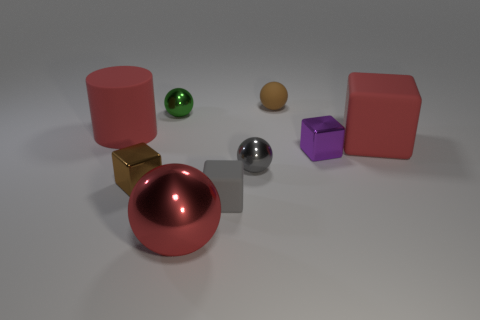What shape is the large metallic object that is the same color as the big block?
Give a very brief answer. Sphere. The large metal object has what color?
Your answer should be very brief. Red. How big is the matte object in front of the big red block?
Keep it short and to the point. Small. There is a red rubber thing to the right of the gray object behind the tiny brown metallic object; how many small brown shiny objects are behind it?
Keep it short and to the point. 0. What is the color of the large rubber object that is behind the red thing that is on the right side of the gray matte block?
Give a very brief answer. Red. Are there any gray objects of the same size as the brown matte ball?
Make the answer very short. Yes. The brown thing behind the matte block that is to the right of the gray thing that is on the right side of the tiny gray cube is made of what material?
Give a very brief answer. Rubber. What number of tiny brown rubber spheres are in front of the red rubber thing right of the red matte cylinder?
Ensure brevity in your answer.  0. There is a shiny ball that is to the right of the gray cube; does it have the same size as the purple shiny block?
Offer a very short reply. Yes. How many tiny brown rubber things are the same shape as the gray matte thing?
Offer a terse response. 0. 